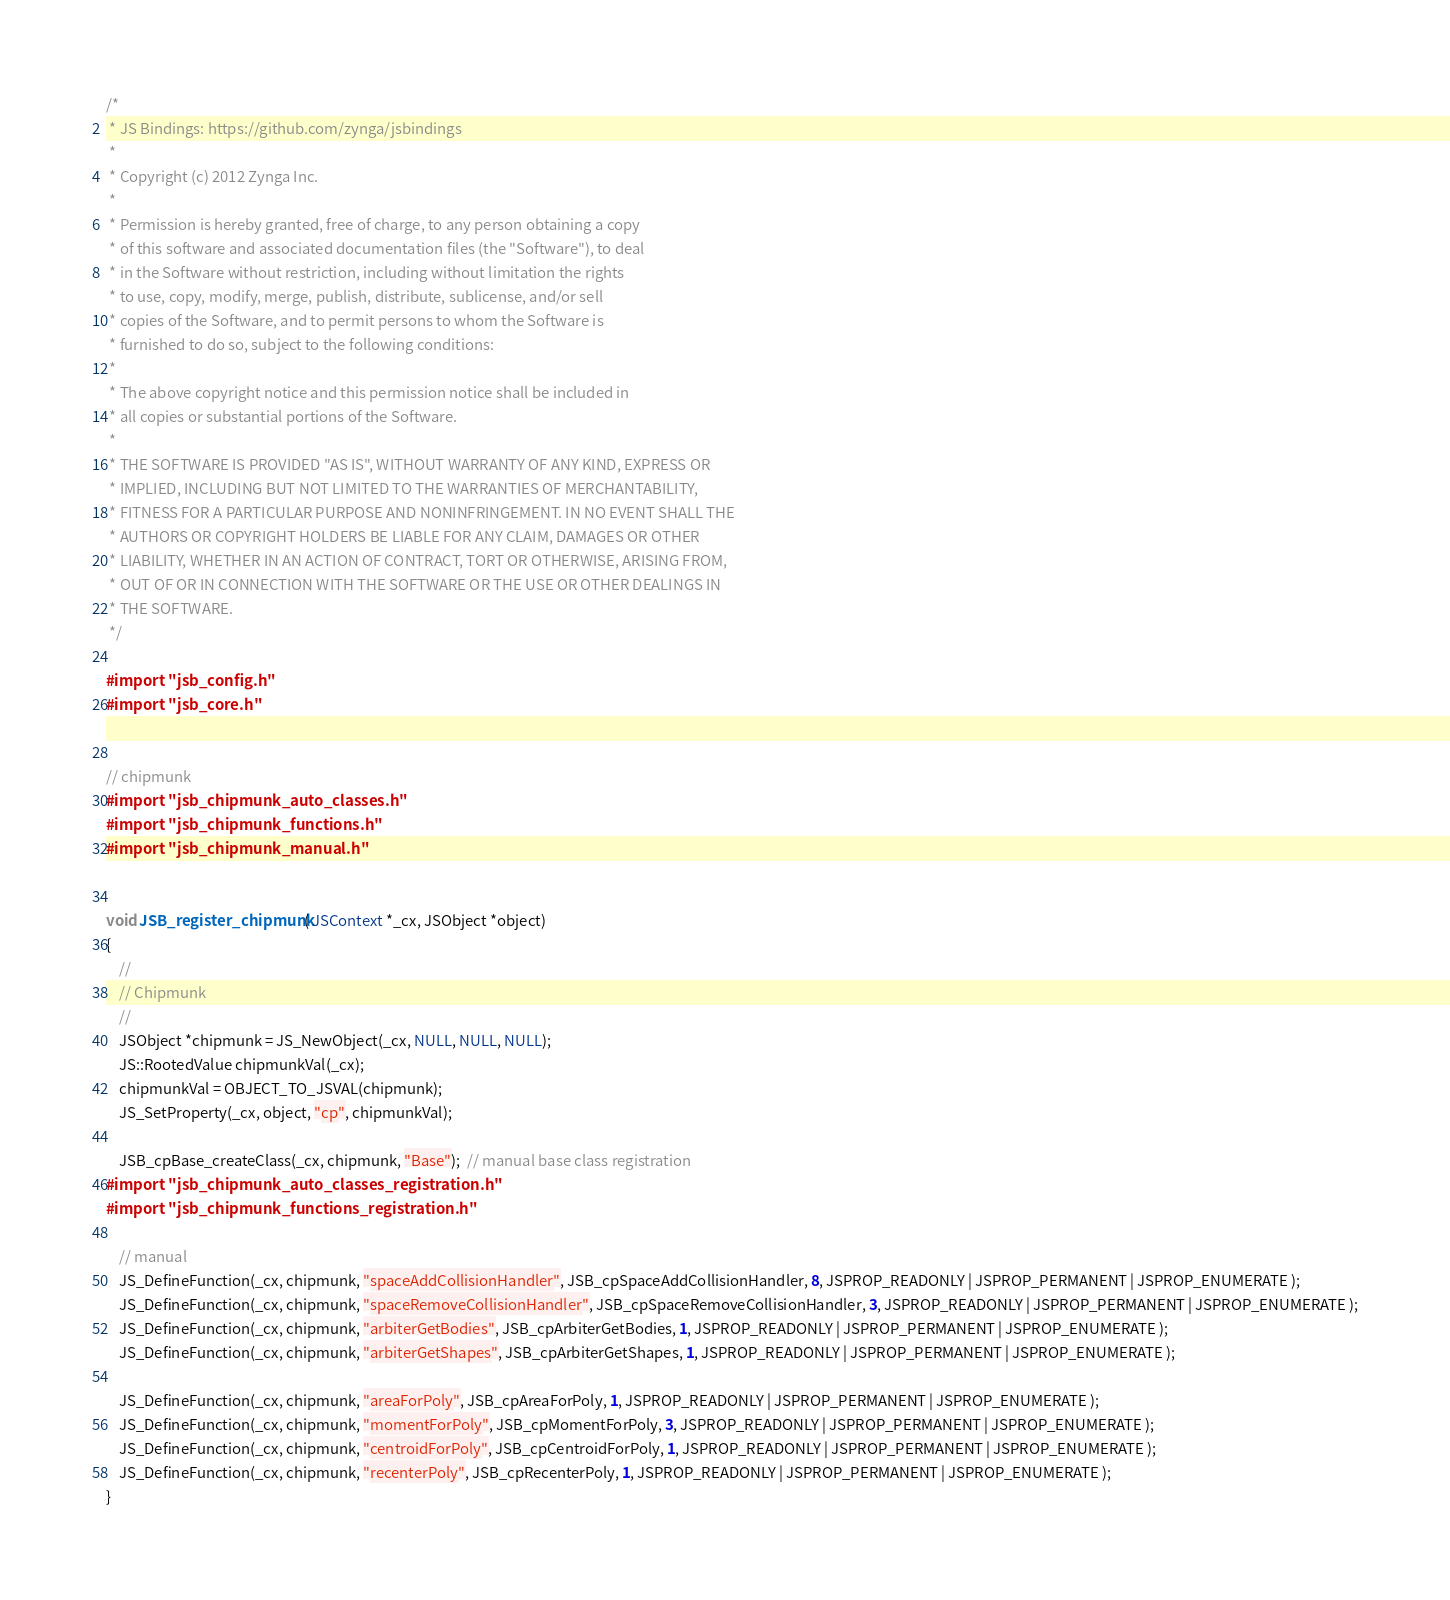<code> <loc_0><loc_0><loc_500><loc_500><_ObjectiveC_>/*
 * JS Bindings: https://github.com/zynga/jsbindings
 *
 * Copyright (c) 2012 Zynga Inc.
 *
 * Permission is hereby granted, free of charge, to any person obtaining a copy
 * of this software and associated documentation files (the "Software"), to deal
 * in the Software without restriction, including without limitation the rights
 * to use, copy, modify, merge, publish, distribute, sublicense, and/or sell
 * copies of the Software, and to permit persons to whom the Software is
 * furnished to do so, subject to the following conditions:
 *
 * The above copyright notice and this permission notice shall be included in
 * all copies or substantial portions of the Software.
 *
 * THE SOFTWARE IS PROVIDED "AS IS", WITHOUT WARRANTY OF ANY KIND, EXPRESS OR
 * IMPLIED, INCLUDING BUT NOT LIMITED TO THE WARRANTIES OF MERCHANTABILITY,
 * FITNESS FOR A PARTICULAR PURPOSE AND NONINFRINGEMENT. IN NO EVENT SHALL THE
 * AUTHORS OR COPYRIGHT HOLDERS BE LIABLE FOR ANY CLAIM, DAMAGES OR OTHER
 * LIABILITY, WHETHER IN AN ACTION OF CONTRACT, TORT OR OTHERWISE, ARISING FROM,
 * OUT OF OR IN CONNECTION WITH THE SOFTWARE OR THE USE OR OTHER DEALINGS IN
 * THE SOFTWARE.
 */

#import "jsb_config.h"
#import "jsb_core.h"


// chipmunk
#import "jsb_chipmunk_auto_classes.h"
#import "jsb_chipmunk_functions.h"
#import "jsb_chipmunk_manual.h"


void JSB_register_chipmunk( JSContext *_cx, JSObject *object)
{
	//
	// Chipmunk
	//
	JSObject *chipmunk = JS_NewObject(_cx, NULL, NULL, NULL);
    JS::RootedValue chipmunkVal(_cx);
    chipmunkVal = OBJECT_TO_JSVAL(chipmunk);
	JS_SetProperty(_cx, object, "cp", chipmunkVal);
	
	JSB_cpBase_createClass(_cx, chipmunk, "Base");  // manual base class registration
#import "jsb_chipmunk_auto_classes_registration.h"
#import "jsb_chipmunk_functions_registration.h"
	
	// manual
	JS_DefineFunction(_cx, chipmunk, "spaceAddCollisionHandler", JSB_cpSpaceAddCollisionHandler, 8, JSPROP_READONLY | JSPROP_PERMANENT | JSPROP_ENUMERATE );
	JS_DefineFunction(_cx, chipmunk, "spaceRemoveCollisionHandler", JSB_cpSpaceRemoveCollisionHandler, 3, JSPROP_READONLY | JSPROP_PERMANENT | JSPROP_ENUMERATE );
	JS_DefineFunction(_cx, chipmunk, "arbiterGetBodies", JSB_cpArbiterGetBodies, 1, JSPROP_READONLY | JSPROP_PERMANENT | JSPROP_ENUMERATE );
	JS_DefineFunction(_cx, chipmunk, "arbiterGetShapes", JSB_cpArbiterGetShapes, 1, JSPROP_READONLY | JSPROP_PERMANENT | JSPROP_ENUMERATE );

	JS_DefineFunction(_cx, chipmunk, "areaForPoly", JSB_cpAreaForPoly, 1, JSPROP_READONLY | JSPROP_PERMANENT | JSPROP_ENUMERATE );
	JS_DefineFunction(_cx, chipmunk, "momentForPoly", JSB_cpMomentForPoly, 3, JSPROP_READONLY | JSPROP_PERMANENT | JSPROP_ENUMERATE );
	JS_DefineFunction(_cx, chipmunk, "centroidForPoly", JSB_cpCentroidForPoly, 1, JSPROP_READONLY | JSPROP_PERMANENT | JSPROP_ENUMERATE );
	JS_DefineFunction(_cx, chipmunk, "recenterPoly", JSB_cpRecenterPoly, 1, JSPROP_READONLY | JSPROP_PERMANENT | JSPROP_ENUMERATE );
}

</code> 